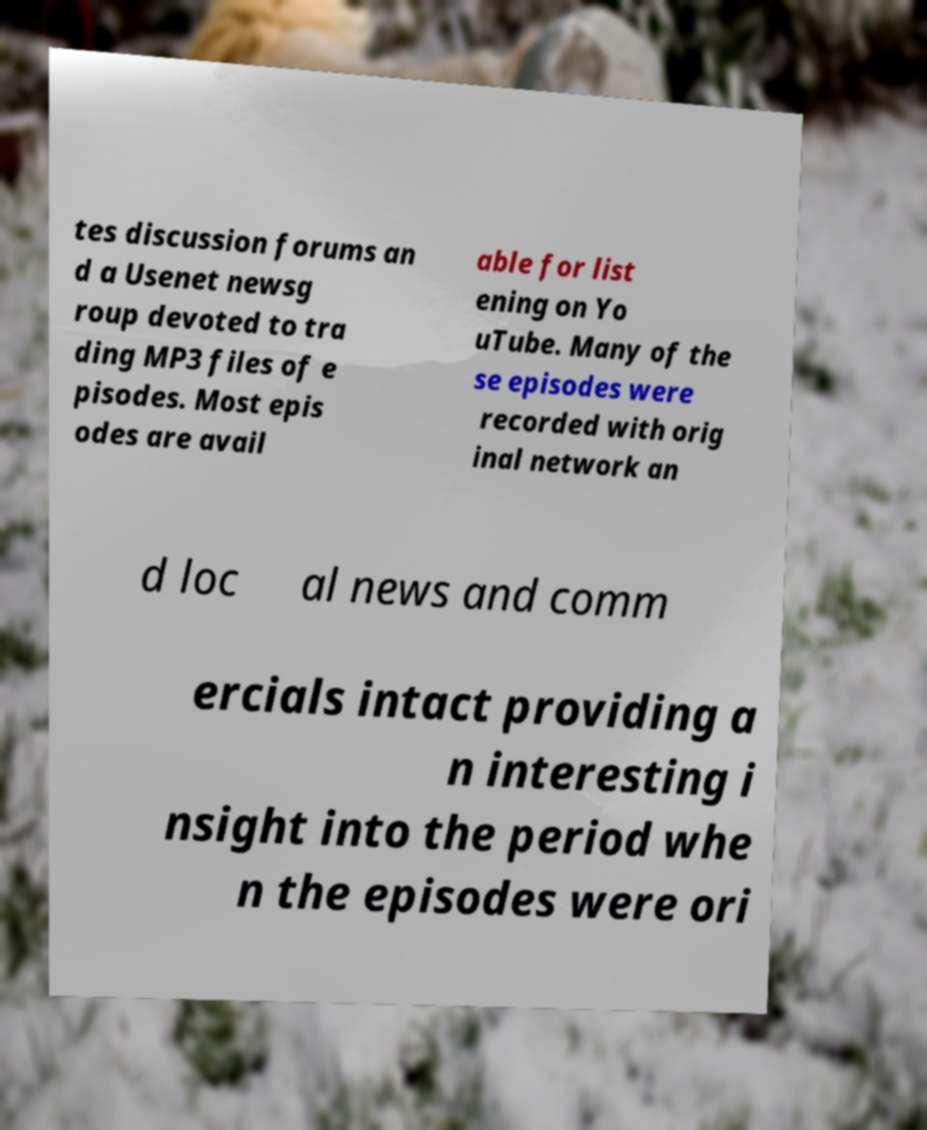There's text embedded in this image that I need extracted. Can you transcribe it verbatim? tes discussion forums an d a Usenet newsg roup devoted to tra ding MP3 files of e pisodes. Most epis odes are avail able for list ening on Yo uTube. Many of the se episodes were recorded with orig inal network an d loc al news and comm ercials intact providing a n interesting i nsight into the period whe n the episodes were ori 